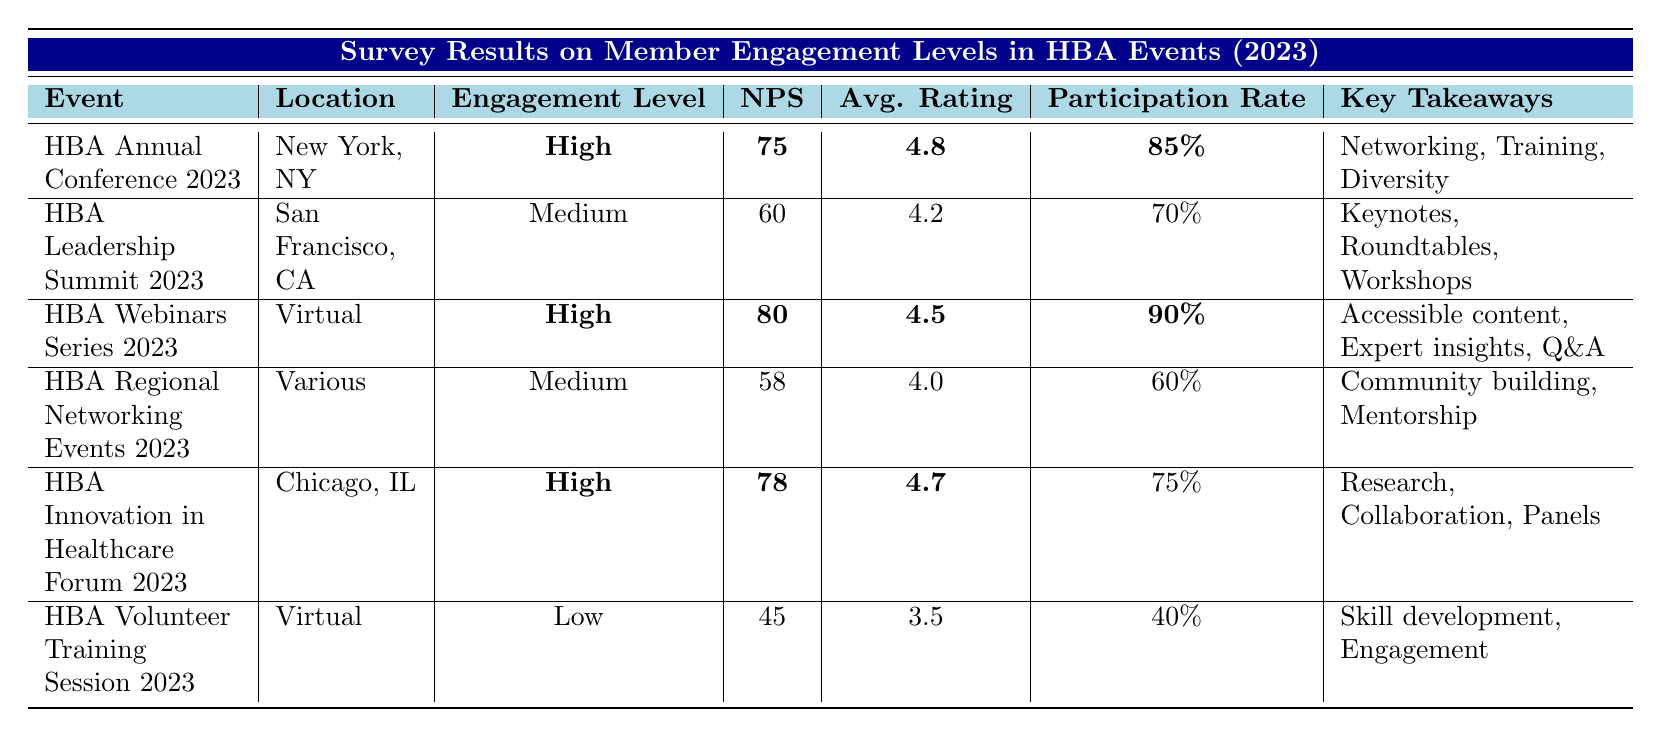What is the net promoter score (NPS) for the HBA Annual Conference 2023? The NPS for the HBA Annual Conference 2023 is displayed in the table, and it is indicated as 75.
Answer: 75 What is the average rating for the HBA Leadership Summit 2023? The average rating for the HBA Leadership Summit 2023 can be found in the average rating column, which shows a value of 4.2.
Answer: 4.2 What was the participation rate for the HBA Volunteer Training Session 2023? The participation rate for the HBA Volunteer Training Session 2023 is given in the table as 40%.
Answer: 40% Are the engagement levels for the HBA Webinars Series 2023 considered high? Yes, the engagement level for the HBA Webinars Series 2023 is highlighted in bold as "High."
Answer: Yes How many events have 'High' engagement levels? By reviewing the engagement level column, it shows that there are three events—HBA Annual Conference 2023, HBA Webinars Series 2023, and HBA Innovation in Healthcare Forum 2023—marked as 'High'.
Answer: 3 What is the difference in net promoter scores between the HBA Webinars Series 2023 and the HBA Volunteer Training Session 2023? The net promoter score for the HBA Webinars Series 2023 is 80, and for the HBA Volunteer Training Session 2023 it is 45. The difference is 80 - 45 = 35.
Answer: 35 What is the average participation rate of events with 'Medium' engagement levels? The events with 'Medium' engagement levels are HBA Leadership Summit 2023 (70%), HBA Regional Networking Events 2023 (60%). To find the average, sum the participation rates (70 + 60) = 130, then divide by 2, resulting in an average of 65%.
Answer: 65% Which event has the highest average rating and what is that rating? The highest average rating is found by scanning the average rating column, and the HBA Annual Conference 2023 has a rating of 4.8, which is the highest.
Answer: 4.8 What key takeaway is common in events with 'High' engagement levels? By comparing the key takeaways from events with 'High' engagement levels, "Collaboration opportunities" appears in at least one takeaway from the HBA Innovation in Healthcare Forum 2023, common in themes of networking and training sessions across other high engagement events implying a focus on collaboration.
Answer: Collaboration opportunities What percentage of participants attended the HBA Regional Networking Events 2023? The participation percentage for the HBA Regional Networking Events 2023 is clearly listed in the table as 60%.
Answer: 60% Is there any event in the table with a net promoter score below 50? Yes, the HBA Volunteer Training Session 2023 has a net promoter score of 45, which is below 50.
Answer: Yes 